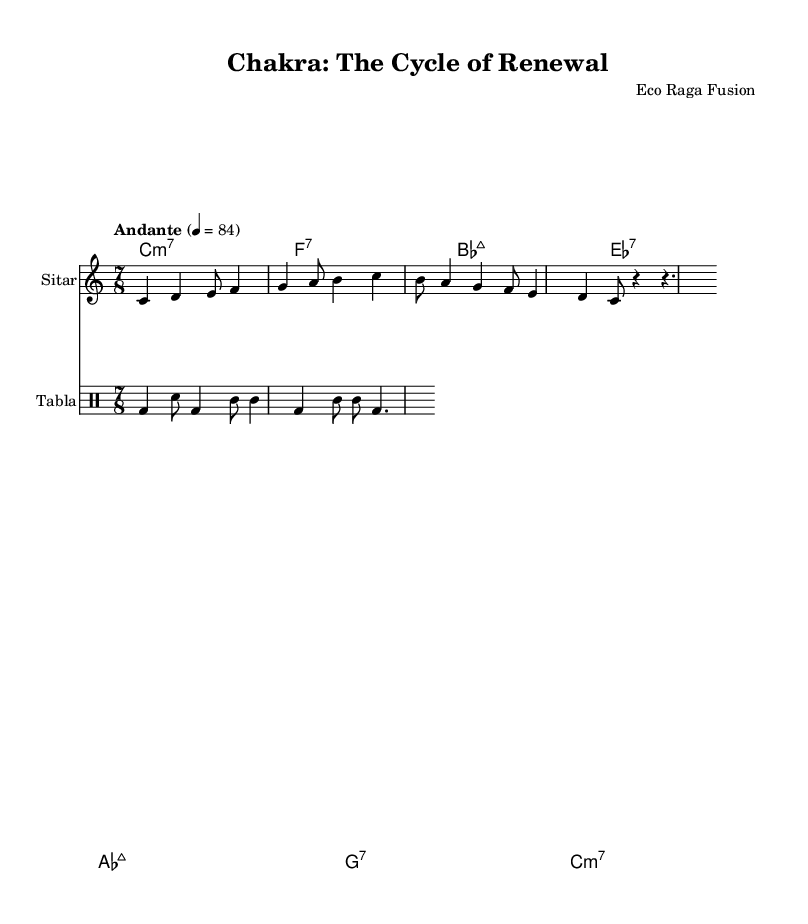What is the key signature of this music? The key signature is indicated at the beginning of the sheet music where it shows the note "C" with no sharps or flats.
Answer: C major What is the time signature of this piece? The time signature is displayed next to the clef and indicates how many beats are in a measure, shown as "7/8" which means there are seven eighth notes per measure.
Answer: 7/8 What is the tempo marking for this composition? The tempo marking is indicated at the beginning of the score with "Andante" followed by a metronome mark of 84, indicating a moderate pace.
Answer: Andante How many measures are in the melody section? To find this, one can count the individual bars in the melody line; there are four distinct measures in the melody section provided.
Answer: 4 What type of scale is predominantly used in the melody? The melody primarily consists of a series of notes from the C major scale, which includes C, D, E, F, G, A, and B, suggesting it uses a major scale structure for its melody.
Answer: Major scale What do the abbreviations "bd," "sn," and "tomml" represent in the tabla part? These abbreviations refer to specific sounds or strokes played on the tabla: "bd" for bass drum, "sn" for snare, and "tomml" likely signifies a hand technique on the tabla, indicating different percussion sounds created.
Answer: Bass drum, snare, tomml Which instruments are involved in this score? The score indicates that there are several parts arranged for different instruments: specifically, a sitar for the melody, a tabla for rhythm, and chord names for harmony above, identifying that this piece is an ensemble work.
Answer: Sitar and tabla 